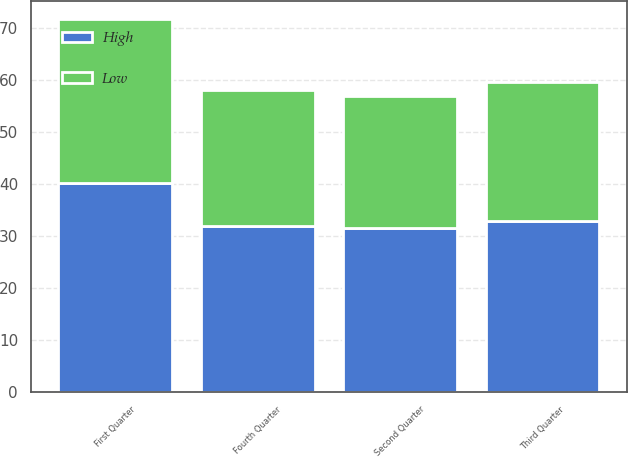<chart> <loc_0><loc_0><loc_500><loc_500><stacked_bar_chart><ecel><fcel>First Quarter<fcel>Second Quarter<fcel>Third Quarter<fcel>Fourth Quarter<nl><fcel>High<fcel>40.22<fcel>31.53<fcel>32.95<fcel>31.92<nl><fcel>Low<fcel>31.53<fcel>25.44<fcel>26.68<fcel>26.29<nl></chart> 